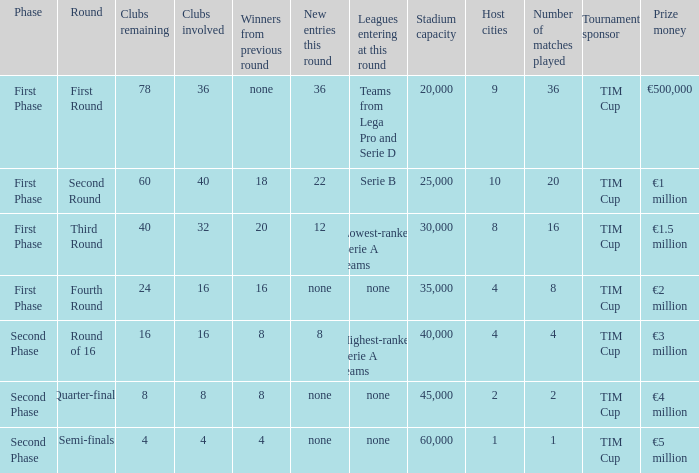Write the full table. {'header': ['Phase', 'Round', 'Clubs remaining', 'Clubs involved', 'Winners from previous round', 'New entries this round', 'Leagues entering at this round', 'Stadium capacity', 'Host cities', 'Number of matches played', 'Tournament sponsor', 'Prize money'], 'rows': [['First Phase', 'First Round', '78', '36', 'none', '36', 'Teams from Lega Pro and Serie D', '20,000', '9', '36', 'TIM Cup', '€500,000'], ['First Phase', 'Second Round', '60', '40', '18', '22', 'Serie B', '25,000', '10', '20', 'TIM Cup', '€1 million'], ['First Phase', 'Third Round', '40', '32', '20', '12', 'Lowest-ranked Serie A teams', '30,000', '8', '16', 'TIM Cup', '€1.5 million'], ['First Phase', 'Fourth Round', '24', '16', '16', 'none', 'none', '35,000', '4', '8', 'TIM Cup', '€2 million'], ['Second Phase', 'Round of 16', '16', '16', '8', '8', 'Highest-ranked Serie A teams', '40,000', '4', '4', 'TIM Cup', '€3 million'], ['Second Phase', 'Quarter-finals', '8', '8', '8', 'none', 'none', '45,000', '2', '2', 'TIM Cup', '€4 million'], ['Second Phase', 'Semi-finals', '4', '4', '4', 'none', 'none', '60,000', '1', '1', 'TIM Cup', '€5 million']]} The new entries this round was shown to be 12, in which phase would you find this? First Phase. 